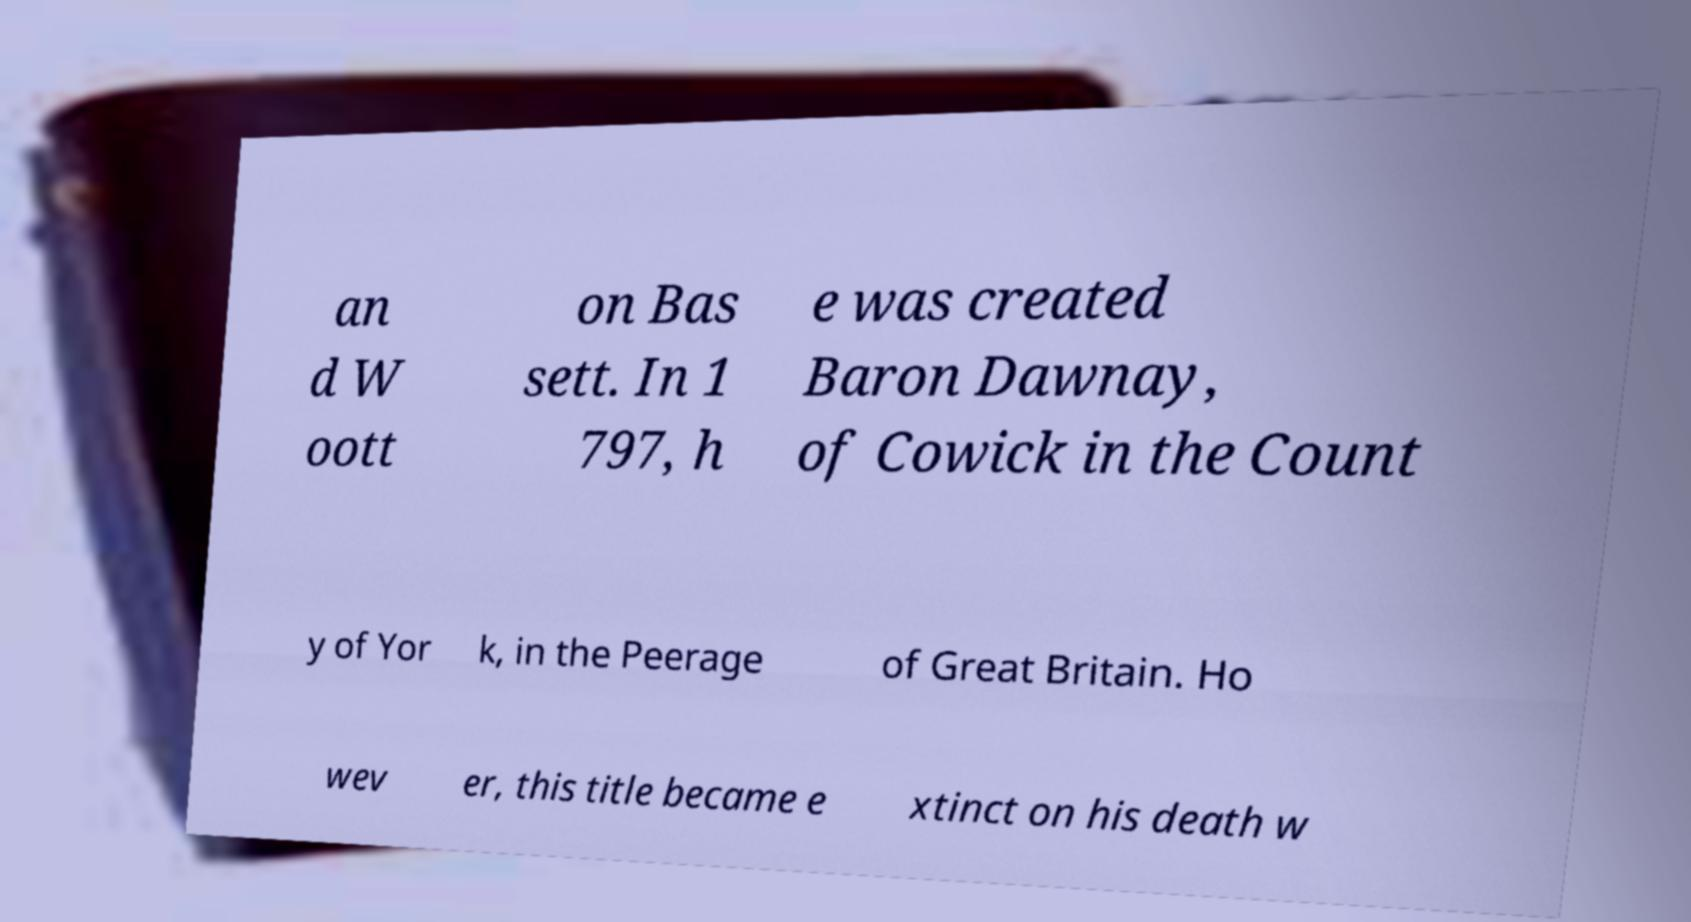Please identify and transcribe the text found in this image. an d W oott on Bas sett. In 1 797, h e was created Baron Dawnay, of Cowick in the Count y of Yor k, in the Peerage of Great Britain. Ho wev er, this title became e xtinct on his death w 